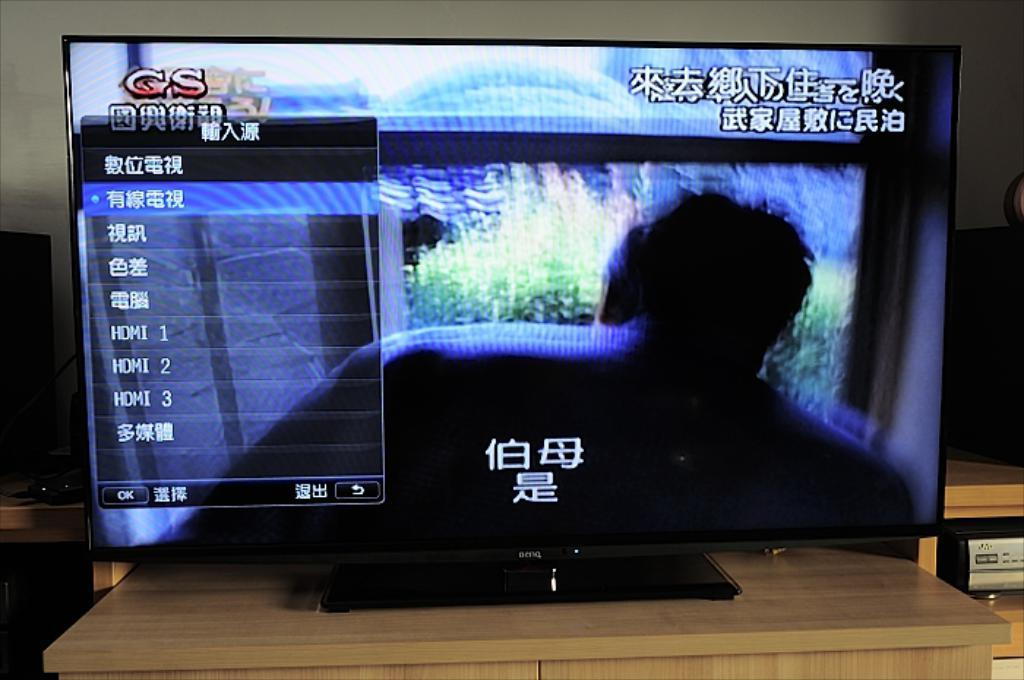<image>
Present a compact description of the photo's key features. Gs is in red letters on the top left of the screen 